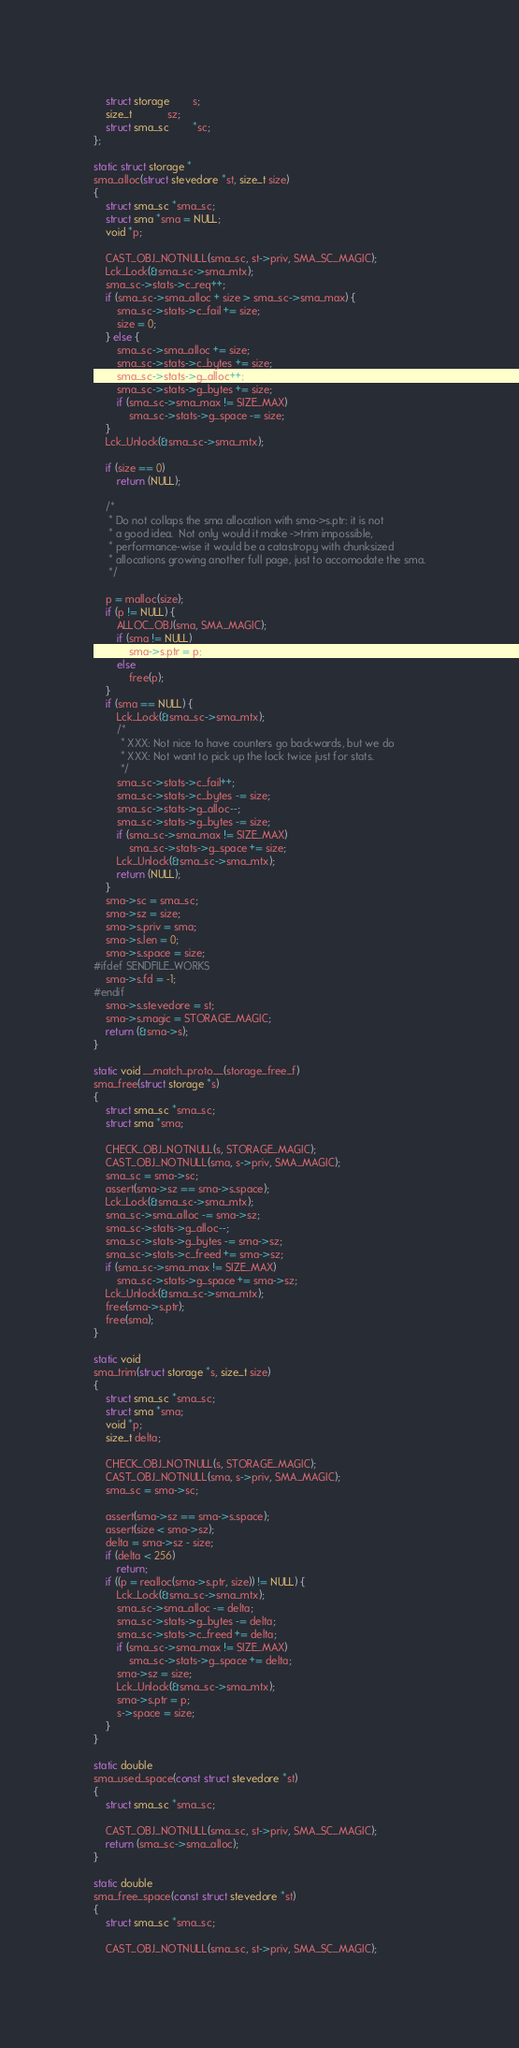Convert code to text. <code><loc_0><loc_0><loc_500><loc_500><_C_>	struct storage		s;
	size_t			sz;
	struct sma_sc		*sc;
};

static struct storage *
sma_alloc(struct stevedore *st, size_t size)
{
	struct sma_sc *sma_sc;
	struct sma *sma = NULL;
	void *p;

	CAST_OBJ_NOTNULL(sma_sc, st->priv, SMA_SC_MAGIC);
	Lck_Lock(&sma_sc->sma_mtx);
	sma_sc->stats->c_req++;
	if (sma_sc->sma_alloc + size > sma_sc->sma_max) {
		sma_sc->stats->c_fail += size;
		size = 0;
	} else {
		sma_sc->sma_alloc += size;
		sma_sc->stats->c_bytes += size;
		sma_sc->stats->g_alloc++;
		sma_sc->stats->g_bytes += size;
		if (sma_sc->sma_max != SIZE_MAX)
			sma_sc->stats->g_space -= size;
	}
	Lck_Unlock(&sma_sc->sma_mtx);

	if (size == 0)
		return (NULL);

	/*
	 * Do not collaps the sma allocation with sma->s.ptr: it is not
	 * a good idea.  Not only would it make ->trim impossible,
	 * performance-wise it would be a catastropy with chunksized
	 * allocations growing another full page, just to accomodate the sma.
	 */

	p = malloc(size);
	if (p != NULL) {
		ALLOC_OBJ(sma, SMA_MAGIC);
		if (sma != NULL)
			sma->s.ptr = p;
		else
			free(p);
	}
	if (sma == NULL) {
		Lck_Lock(&sma_sc->sma_mtx);
		/*
		 * XXX: Not nice to have counters go backwards, but we do
		 * XXX: Not want to pick up the lock twice just for stats.
		 */
		sma_sc->stats->c_fail++;
		sma_sc->stats->c_bytes -= size;
		sma_sc->stats->g_alloc--;
		sma_sc->stats->g_bytes -= size;
		if (sma_sc->sma_max != SIZE_MAX)
			sma_sc->stats->g_space += size;
		Lck_Unlock(&sma_sc->sma_mtx);
		return (NULL);
	}
	sma->sc = sma_sc;
	sma->sz = size;
	sma->s.priv = sma;
	sma->s.len = 0;
	sma->s.space = size;
#ifdef SENDFILE_WORKS
	sma->s.fd = -1;
#endif
	sma->s.stevedore = st;
	sma->s.magic = STORAGE_MAGIC;
	return (&sma->s);
}

static void __match_proto__(storage_free_f)
sma_free(struct storage *s)
{
	struct sma_sc *sma_sc;
	struct sma *sma;

	CHECK_OBJ_NOTNULL(s, STORAGE_MAGIC);
	CAST_OBJ_NOTNULL(sma, s->priv, SMA_MAGIC);
	sma_sc = sma->sc;
	assert(sma->sz == sma->s.space);
	Lck_Lock(&sma_sc->sma_mtx);
	sma_sc->sma_alloc -= sma->sz;
	sma_sc->stats->g_alloc--;
	sma_sc->stats->g_bytes -= sma->sz;
	sma_sc->stats->c_freed += sma->sz;
	if (sma_sc->sma_max != SIZE_MAX)
		sma_sc->stats->g_space += sma->sz;
	Lck_Unlock(&sma_sc->sma_mtx);
	free(sma->s.ptr);
	free(sma);
}

static void
sma_trim(struct storage *s, size_t size)
{
	struct sma_sc *sma_sc;
	struct sma *sma;
	void *p;
	size_t delta;

	CHECK_OBJ_NOTNULL(s, STORAGE_MAGIC);
	CAST_OBJ_NOTNULL(sma, s->priv, SMA_MAGIC);
	sma_sc = sma->sc;

	assert(sma->sz == sma->s.space);
	assert(size < sma->sz);
	delta = sma->sz - size;
	if (delta < 256)
		return;
	if ((p = realloc(sma->s.ptr, size)) != NULL) {
		Lck_Lock(&sma_sc->sma_mtx);
		sma_sc->sma_alloc -= delta;
		sma_sc->stats->g_bytes -= delta;
		sma_sc->stats->c_freed += delta;
		if (sma_sc->sma_max != SIZE_MAX)
			sma_sc->stats->g_space += delta;
		sma->sz = size;
		Lck_Unlock(&sma_sc->sma_mtx);
		sma->s.ptr = p;
		s->space = size;
	}
}

static double
sma_used_space(const struct stevedore *st)
{
	struct sma_sc *sma_sc;

	CAST_OBJ_NOTNULL(sma_sc, st->priv, SMA_SC_MAGIC);
	return (sma_sc->sma_alloc);
}

static double
sma_free_space(const struct stevedore *st)
{
	struct sma_sc *sma_sc;

	CAST_OBJ_NOTNULL(sma_sc, st->priv, SMA_SC_MAGIC);</code> 